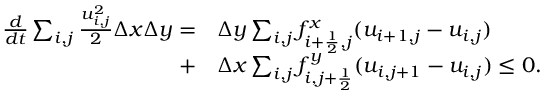Convert formula to latex. <formula><loc_0><loc_0><loc_500><loc_500>\begin{array} { r l } { \frac { d } { d t } \sum _ { i , j } \frac { u _ { i , j } ^ { 2 } } { 2 } \Delta x \Delta y = } & \Delta y \sum _ { i , j } f _ { i + \frac { 1 } { 2 } , j } ^ { x } ( u _ { i + 1 , j } - u _ { i , j } ) } \\ { + } & \Delta x \sum _ { i , j } f _ { i , j + \frac { 1 } { 2 } } ^ { y } ( u _ { i , j + 1 } - u _ { i , j } ) \leq 0 . } \end{array}</formula> 